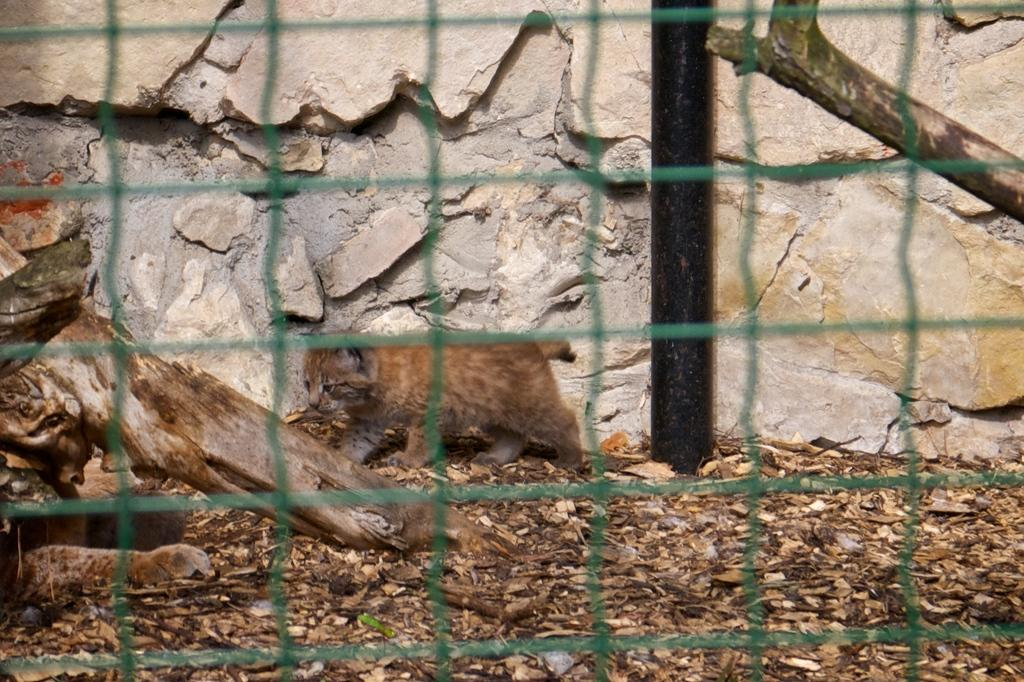What type of material is visible in the image? There is a mesh in the image. What can be seen in the background of the image? There is an animal and a wall in the background of the image. What is the material of the wooden piece in the image? There is a wooden piece in the image. What other object can be seen in the image? There is a pole in the image. What type of lamp is hanging from the mesh in the image? There is no lamp present in the image; it only features a mesh, an animal, a wooden piece, a wall, and a pole. How many ears can be seen on the animal in the image? There is no animal with ears visible in the image; it only features an animal in the background, but no specific details about the animal are provided. 